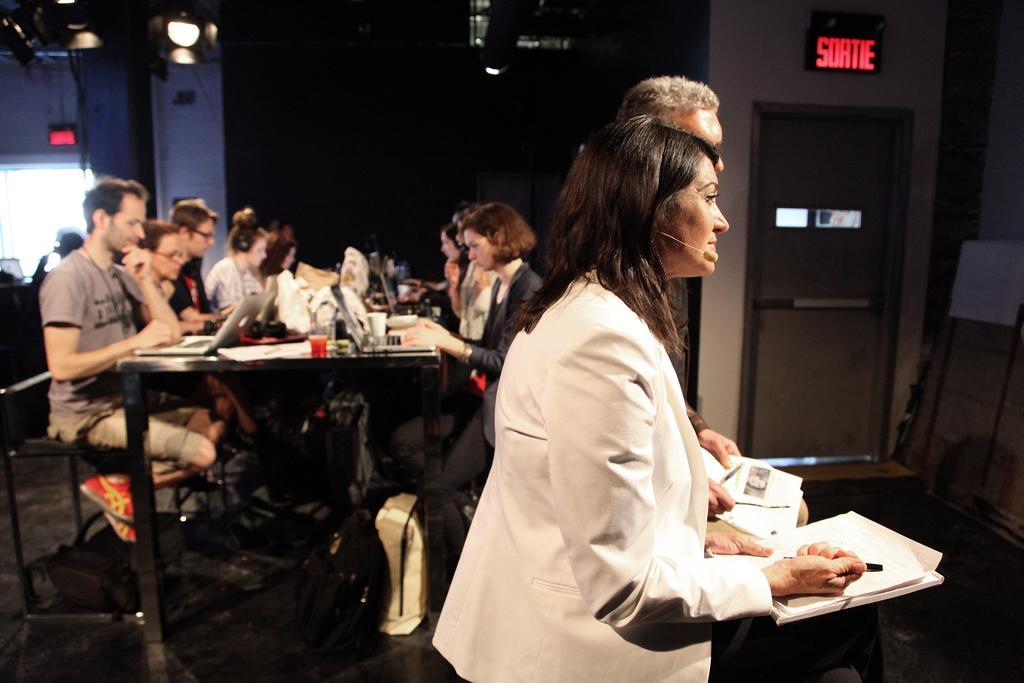Could you give a brief overview of what you see in this image? In this picture there is a woman who is wearing white suit and microphone. she is standing near to the speech desk. On the desk I can see the books, papers and pen. beside her there is an old man. In the back I can see many peoples were sitting on the chair near to the table and they are looking on the laptop. On the table I can see laptops, tissue papers, papers, books, water bottles, glass and other objects. On the right there is a door. Beside that I can see the board and projector screen. In the top left corner I can see some lights. Bottom of the table I can see many bags. 